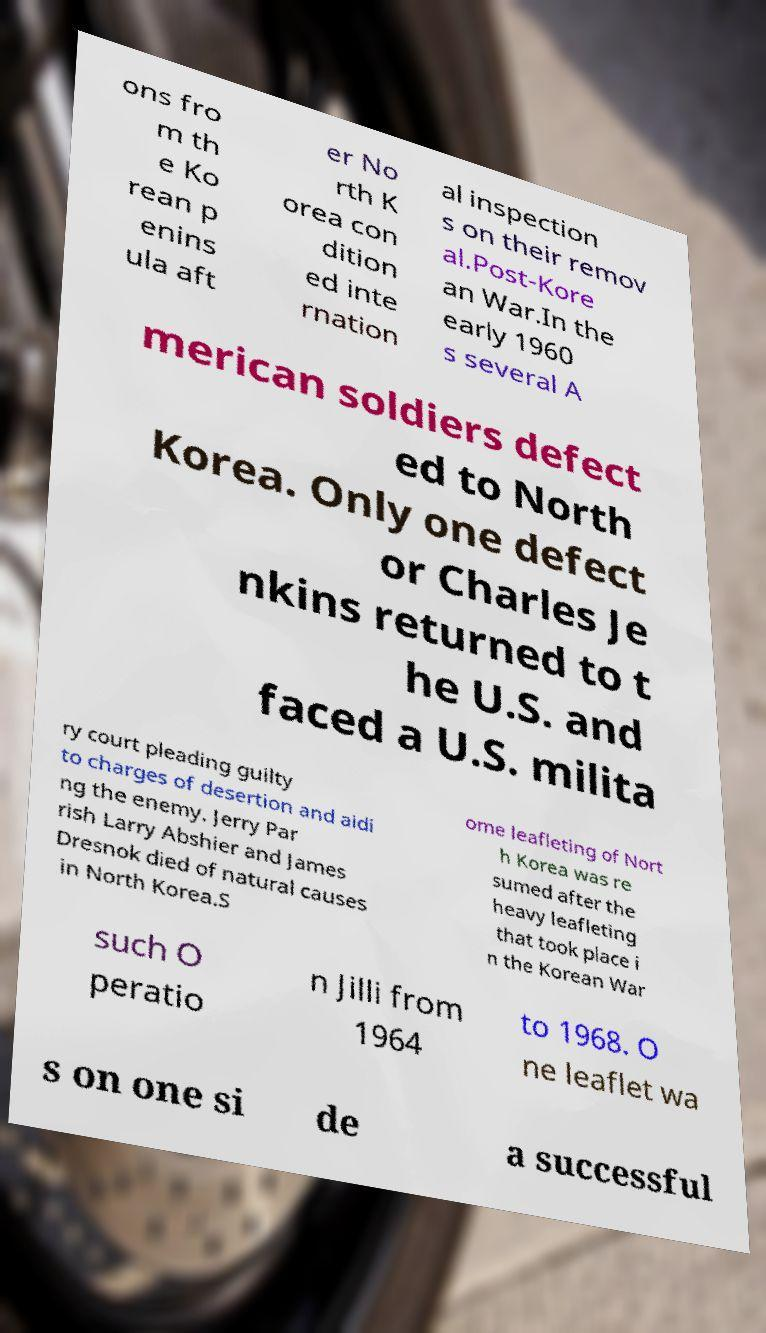Can you accurately transcribe the text from the provided image for me? ons fro m th e Ko rean p enins ula aft er No rth K orea con dition ed inte rnation al inspection s on their remov al.Post-Kore an War.In the early 1960 s several A merican soldiers defect ed to North Korea. Only one defect or Charles Je nkins returned to t he U.S. and faced a U.S. milita ry court pleading guilty to charges of desertion and aidi ng the enemy. Jerry Par rish Larry Abshier and James Dresnok died of natural causes in North Korea.S ome leafleting of Nort h Korea was re sumed after the heavy leafleting that took place i n the Korean War such O peratio n Jilli from 1964 to 1968. O ne leaflet wa s on one si de a successful 